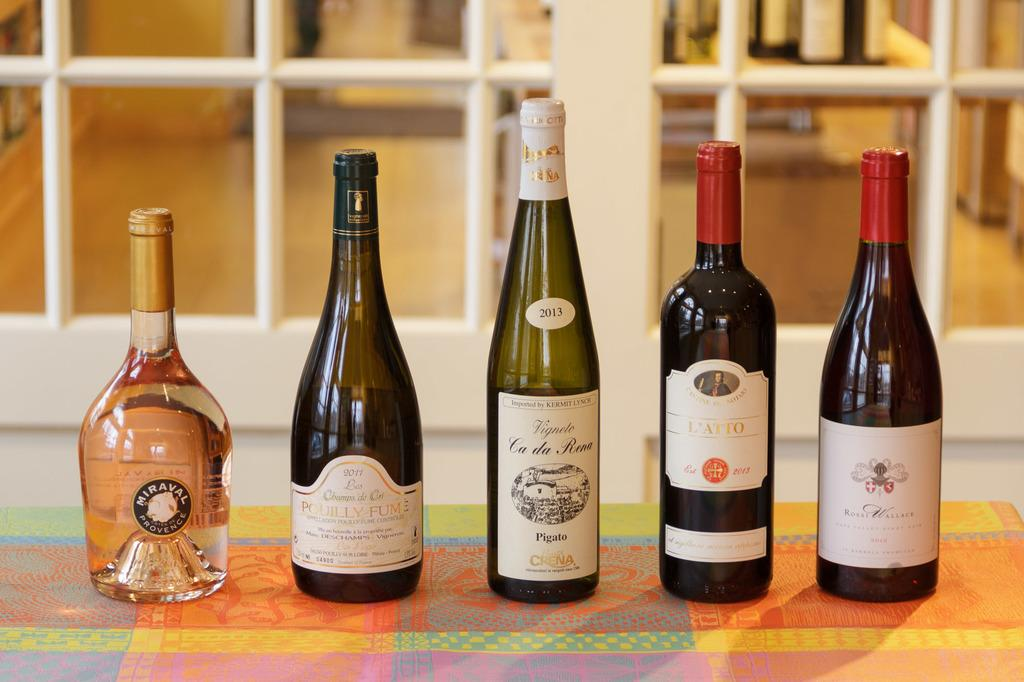<image>
Summarize the visual content of the image. A bottle of Miraval Provence in a row of bottles on a table. 